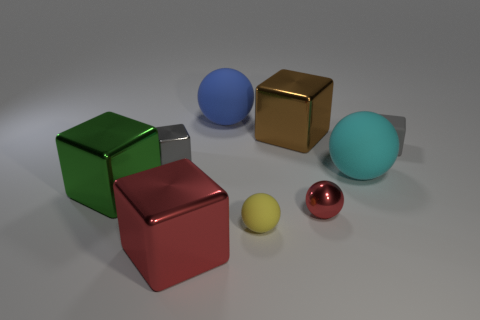Subtract all tiny red metal spheres. How many spheres are left? 3 Subtract all gray blocks. How many blocks are left? 3 Subtract 2 balls. How many balls are left? 2 Subtract 0 red cylinders. How many objects are left? 9 Subtract all balls. How many objects are left? 5 Subtract all green blocks. Subtract all blue cylinders. How many blocks are left? 4 Subtract all gray cubes. How many green balls are left? 0 Subtract all small yellow rubber things. Subtract all yellow objects. How many objects are left? 7 Add 6 big green objects. How many big green objects are left? 7 Add 7 gray objects. How many gray objects exist? 9 